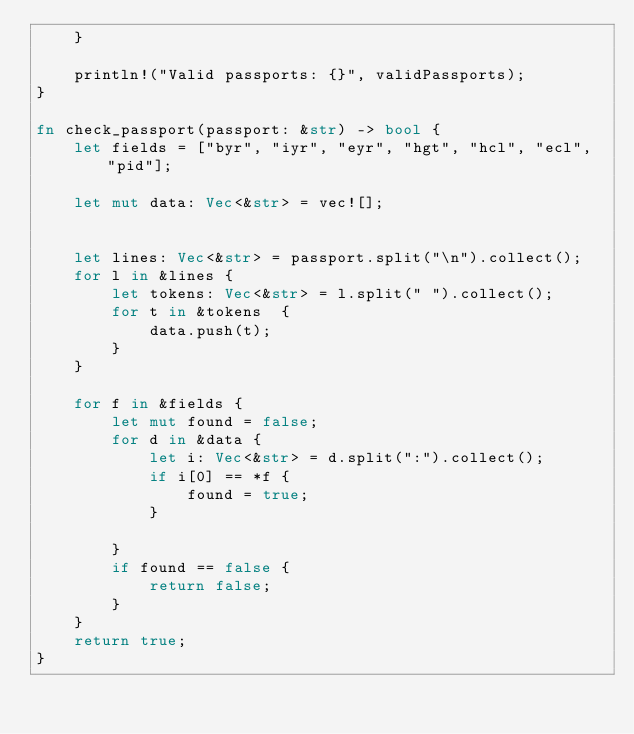<code> <loc_0><loc_0><loc_500><loc_500><_Rust_>    }

    println!("Valid passports: {}", validPassports);
}

fn check_passport(passport: &str) -> bool {
    let fields = ["byr", "iyr", "eyr", "hgt", "hcl", "ecl", "pid"];

    let mut data: Vec<&str> = vec![];


    let lines: Vec<&str> = passport.split("\n").collect();
    for l in &lines {
        let tokens: Vec<&str> = l.split(" ").collect();
        for t in &tokens  {
            data.push(t);
        }
    }

    for f in &fields {
        let mut found = false;
        for d in &data {
            let i: Vec<&str> = d.split(":").collect();
            if i[0] == *f {
                found = true;
            }

        }
        if found == false {
            return false;
        }
    }
    return true;
}
</code> 